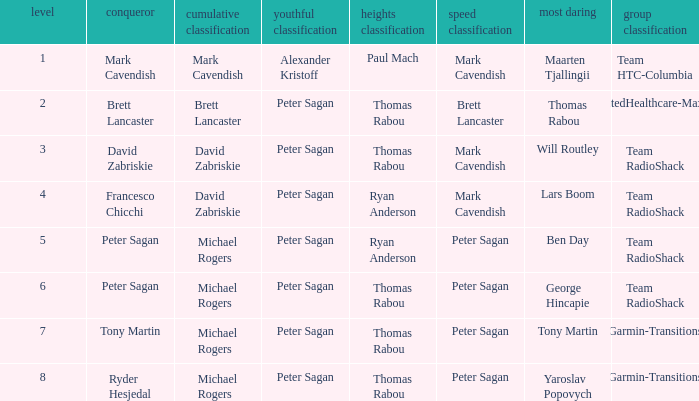When Peter Sagan won the youth classification and Thomas Rabou won the most corageous, who won the sprint classification? Brett Lancaster. Could you help me parse every detail presented in this table? {'header': ['level', 'conqueror', 'cumulative classification', 'youthful classification', 'heights classification', 'speed classification', 'most daring', 'group classification'], 'rows': [['1', 'Mark Cavendish', 'Mark Cavendish', 'Alexander Kristoff', 'Paul Mach', 'Mark Cavendish', 'Maarten Tjallingii', 'Team HTC-Columbia'], ['2', 'Brett Lancaster', 'Brett Lancaster', 'Peter Sagan', 'Thomas Rabou', 'Brett Lancaster', 'Thomas Rabou', 'UnitedHealthcare-Maxxis'], ['3', 'David Zabriskie', 'David Zabriskie', 'Peter Sagan', 'Thomas Rabou', 'Mark Cavendish', 'Will Routley', 'Team RadioShack'], ['4', 'Francesco Chicchi', 'David Zabriskie', 'Peter Sagan', 'Ryan Anderson', 'Mark Cavendish', 'Lars Boom', 'Team RadioShack'], ['5', 'Peter Sagan', 'Michael Rogers', 'Peter Sagan', 'Ryan Anderson', 'Peter Sagan', 'Ben Day', 'Team RadioShack'], ['6', 'Peter Sagan', 'Michael Rogers', 'Peter Sagan', 'Thomas Rabou', 'Peter Sagan', 'George Hincapie', 'Team RadioShack'], ['7', 'Tony Martin', 'Michael Rogers', 'Peter Sagan', 'Thomas Rabou', 'Peter Sagan', 'Tony Martin', 'Garmin-Transitions'], ['8', 'Ryder Hesjedal', 'Michael Rogers', 'Peter Sagan', 'Thomas Rabou', 'Peter Sagan', 'Yaroslav Popovych', 'Garmin-Transitions']]} 